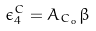Convert formula to latex. <formula><loc_0><loc_0><loc_500><loc_500>\epsilon _ { 4 } ^ { C } = A _ { C _ { o } } \beta</formula> 